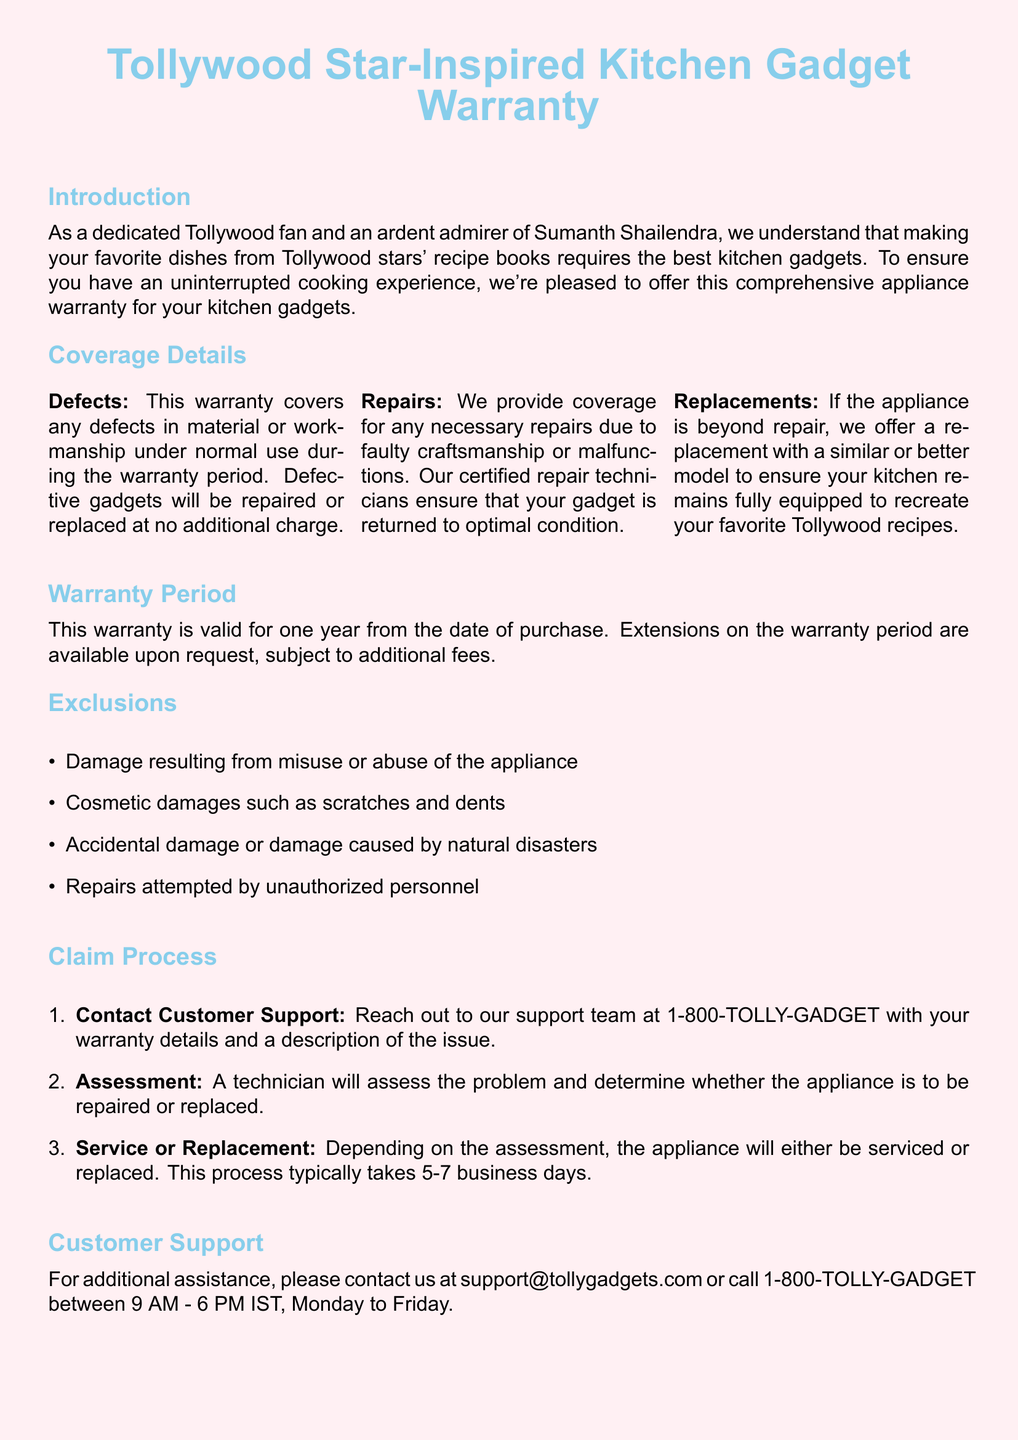What is the warranty period? The warranty period is specified in the document as one year from the date of purchase.
Answer: one year What is the customer support contact number? Customer support contact information is provided in the document, and the number is 1-800-TOLLY-GADGET.
Answer: 1-800-TOLLY-GADGET What does the warranty cover? The document lists coverage for defects, repairs, and replacements for the kitchen gadgets.
Answer: defects, repairs, and replacements What should you do to initiate a claim? The first step in the claim process is to contact customer support with warranty details.
Answer: contact customer support How long does the claim process typically take? The document states that the process typically takes 5-7 business days.
Answer: 5-7 business days What types of damages are excluded from coverage? The document provides a list of exclusions, including misuse and cosmetic damages.
Answer: misuse and cosmetic damages Can the warranty period be extended? It is mentioned in the document that extensions on the warranty period are available upon request.
Answer: yes Who assesses the appliance problem? The document specifies that a technician will assess the problem after contacting customer support.
Answer: technician 